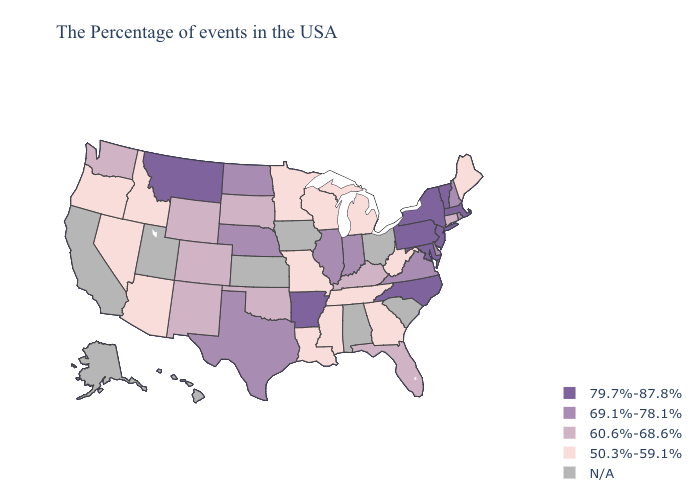Does Nevada have the highest value in the USA?
Concise answer only. No. Name the states that have a value in the range 69.1%-78.1%?
Write a very short answer. Rhode Island, New Hampshire, Delaware, Virginia, Indiana, Illinois, Nebraska, Texas, North Dakota. Name the states that have a value in the range 69.1%-78.1%?
Answer briefly. Rhode Island, New Hampshire, Delaware, Virginia, Indiana, Illinois, Nebraska, Texas, North Dakota. Name the states that have a value in the range 60.6%-68.6%?
Short answer required. Connecticut, Florida, Kentucky, Oklahoma, South Dakota, Wyoming, Colorado, New Mexico, Washington. Does North Carolina have the highest value in the South?
Short answer required. Yes. How many symbols are there in the legend?
Keep it brief. 5. What is the value of North Dakota?
Keep it brief. 69.1%-78.1%. What is the lowest value in the West?
Answer briefly. 50.3%-59.1%. What is the value of New Mexico?
Answer briefly. 60.6%-68.6%. What is the lowest value in the South?
Be succinct. 50.3%-59.1%. What is the highest value in the MidWest ?
Be succinct. 69.1%-78.1%. What is the value of Texas?
Concise answer only. 69.1%-78.1%. Among the states that border Indiana , does Kentucky have the lowest value?
Answer briefly. No. How many symbols are there in the legend?
Be succinct. 5. Is the legend a continuous bar?
Concise answer only. No. 